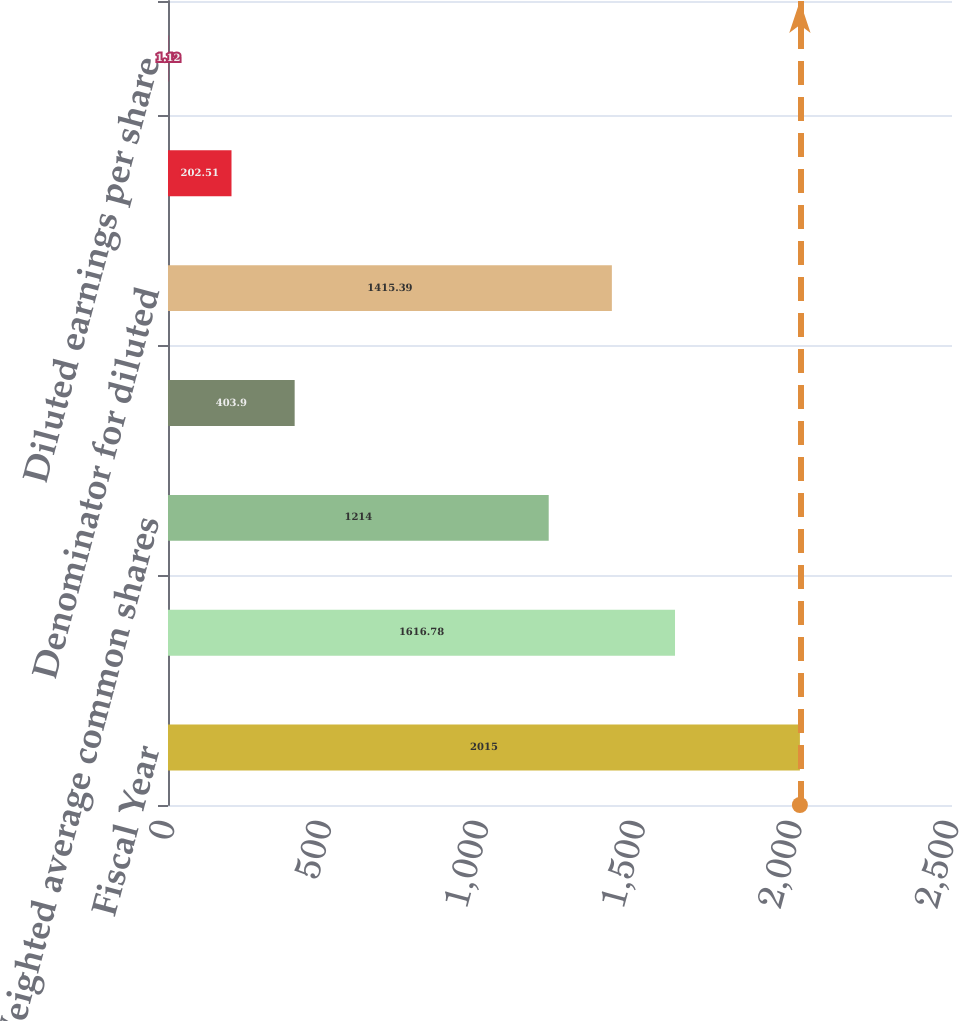Convert chart. <chart><loc_0><loc_0><loc_500><loc_500><bar_chart><fcel>Fiscal Year<fcel>Net income<fcel>Weighted average common shares<fcel>Effect of dilutive stock<fcel>Denominator for diluted<fcel>Basic earnings per share<fcel>Diluted earnings per share<nl><fcel>2015<fcel>1616.78<fcel>1214<fcel>403.9<fcel>1415.39<fcel>202.51<fcel>1.12<nl></chart> 